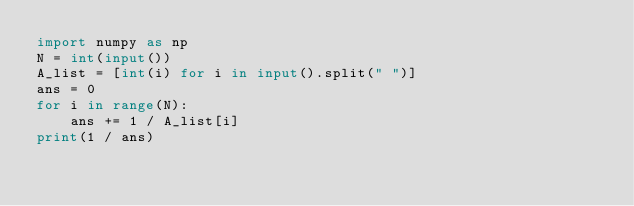Convert code to text. <code><loc_0><loc_0><loc_500><loc_500><_Python_>import numpy as np
N = int(input())
A_list = [int(i) for i in input().split(" ")]
ans = 0
for i in range(N):
    ans += 1 / A_list[i]
print(1 / ans)
</code> 